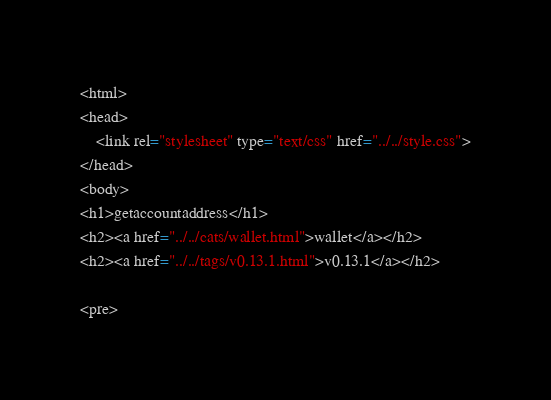<code> <loc_0><loc_0><loc_500><loc_500><_HTML_><html>
<head>
    <link rel="stylesheet" type="text/css" href="../../style.css">
</head>
<body>
<h1>getaccountaddress</h1>
<h2><a href="../../cats/wallet.html">wallet</a></h2>
<h2><a href="../../tags/v0.13.1.html">v0.13.1</a></h2>

<pre></code> 